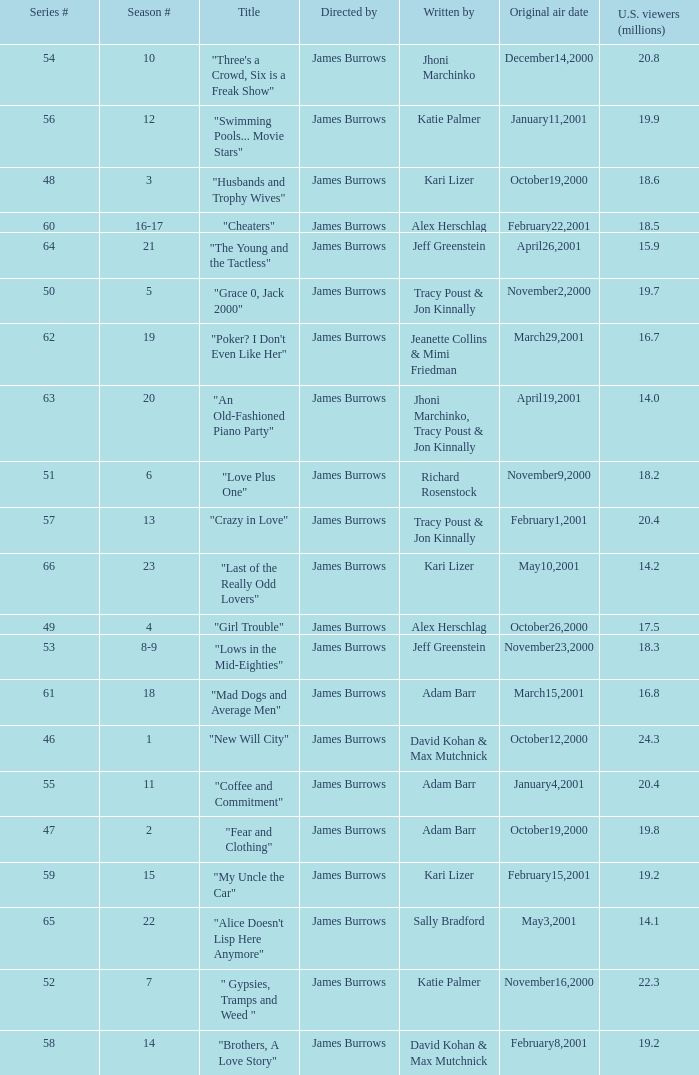Who wrote episode 23 in the season? Kari Lizer. 